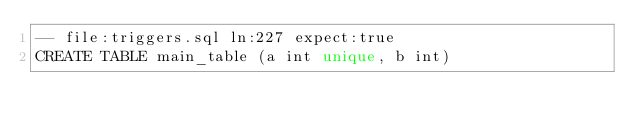<code> <loc_0><loc_0><loc_500><loc_500><_SQL_>-- file:triggers.sql ln:227 expect:true
CREATE TABLE main_table (a int unique, b int)
</code> 